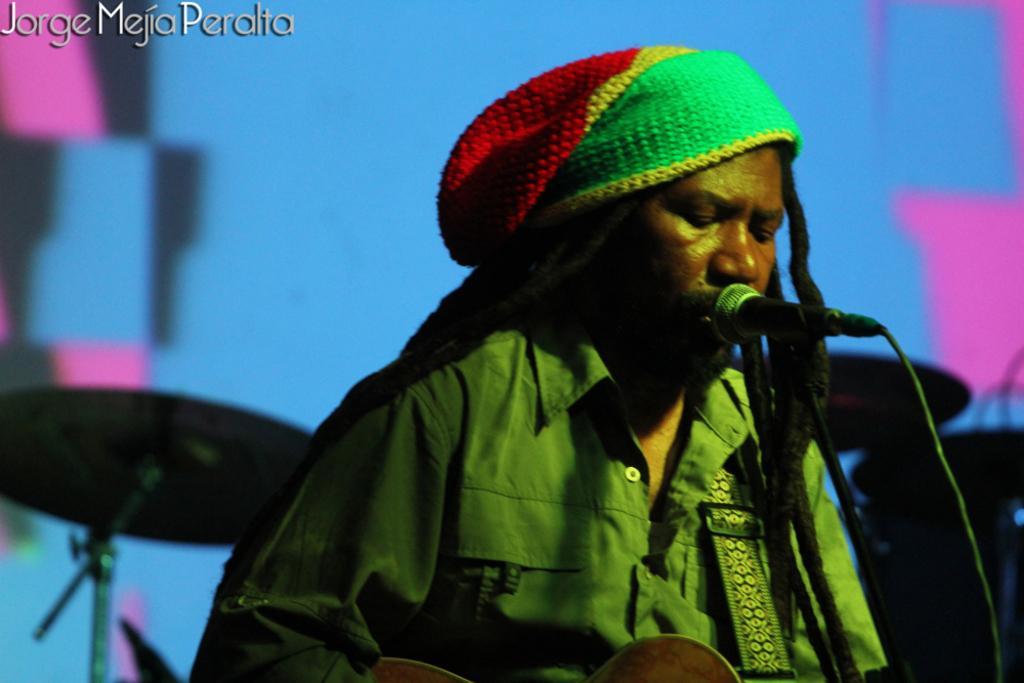Can you describe this image briefly? In this image I can see a person standing in front of the mic. In the background I can see few musical instruments. At the top right hand corner I can see some text. 